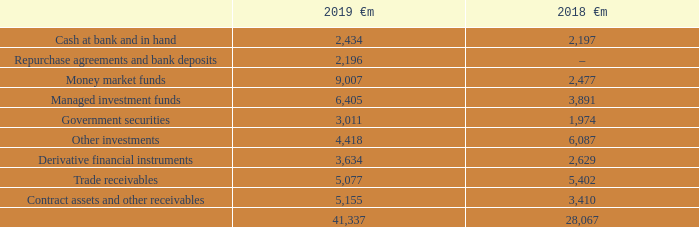Financial risk management
The Group’s treasury function centrally manages the Group’s funding requirement, net foreign exchange exposure, interest rate management exposures and counterparty risk arising from investments and derivatives.
Treasury operations are conducted within a framework of policies and guidelines authorised and reviewed by the Board, most recently in July 2018
A treasury risk committee comprising of the Group’s Chief Financial Officer, Group General Counsel and Company Secretary, Group Financial Controller, Group Treasury Director and Group Director of Financial Controlling and Operations meets three times a year to review treasury activities and its members receive management information relating to treasury activities on a quarterly basis. The Group’s accounting function, which does not report to the Group Treasury Director, provides regular update reports of treasury activity to the Board. The Group’s internal auditor reviews the internal control environment regularly.
The Group uses a number of derivative instruments for currency and interest rate risk management purposes only that are transacted by specialist treasury personnel. The Group mitigates banking sector credit risk by the use of collateral support agreements.
Credit risk
Credit risk is the risk that a counterparty will not meet its obligations under a financial asset leading to a financial loss for the Group. The Group is exposed to credit risk from its operating activities and from its financing activities, the Group considers its maximum exposure to credit risk at 31 March to be:
Expected credit loss
The Group has financial assets classified and measured at amortised cost and fair value through other comprehensive income that are subject to the expected credit loss model requirements of IFRS 9. Cash at bank and in hand and certain other investments are both classified and measured at amortised cost and subject to these impairment requirements. However, the identified expected credit loss is considered to be immaterial.
Information about expected credit losses for trade receivables and contract assets can be found under “operating activities” on page 164.
Which financial years' information is shown in the table? 2018, 2019. How much is 2019 cash at bank and in hand ?
Answer scale should be: million. 2,434. How much is 2018 cash at bank and in hand ?
Answer scale should be: million. 2,197. Between 2018 and 2019, which year had a greater amount of money market funds? 9,007>2,477
Answer: 2019. Between 2018 and 2019, which year had a greater amount of managed investment funds? 6,405>3,891
Answer: 2019. Between 2018 and 2019, which year had a greater amount of government securities? 3,011>1,974
Answer: 2019. 